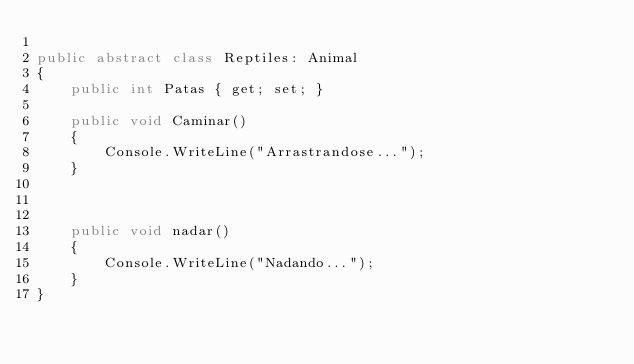Convert code to text. <code><loc_0><loc_0><loc_500><loc_500><_C#_>
public abstract class Reptiles: Animal
{
    public int Patas { get; set; }

    public void Caminar()
    {
        Console.WriteLine("Arrastrandose...");
    }



    public void nadar()
    {
        Console.WriteLine("Nadando...");
    }
}</code> 